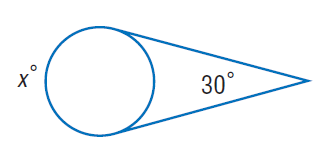Answer the mathemtical geometry problem and directly provide the correct option letter.
Question: Find x. Assume that any segment that appears to be tangent is tangent.
Choices: A: 30 B: 120 C: 150 D: 210 D 